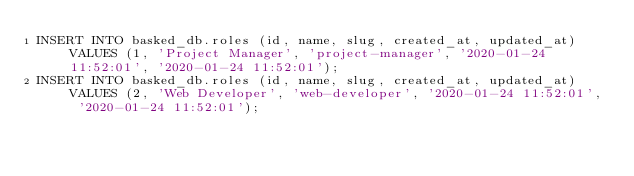Convert code to text. <code><loc_0><loc_0><loc_500><loc_500><_SQL_>INSERT INTO basked_db.roles (id, name, slug, created_at, updated_at) VALUES (1, 'Project Manager', 'project-manager', '2020-01-24 11:52:01', '2020-01-24 11:52:01');
INSERT INTO basked_db.roles (id, name, slug, created_at, updated_at) VALUES (2, 'Web Developer', 'web-developer', '2020-01-24 11:52:01', '2020-01-24 11:52:01');</code> 